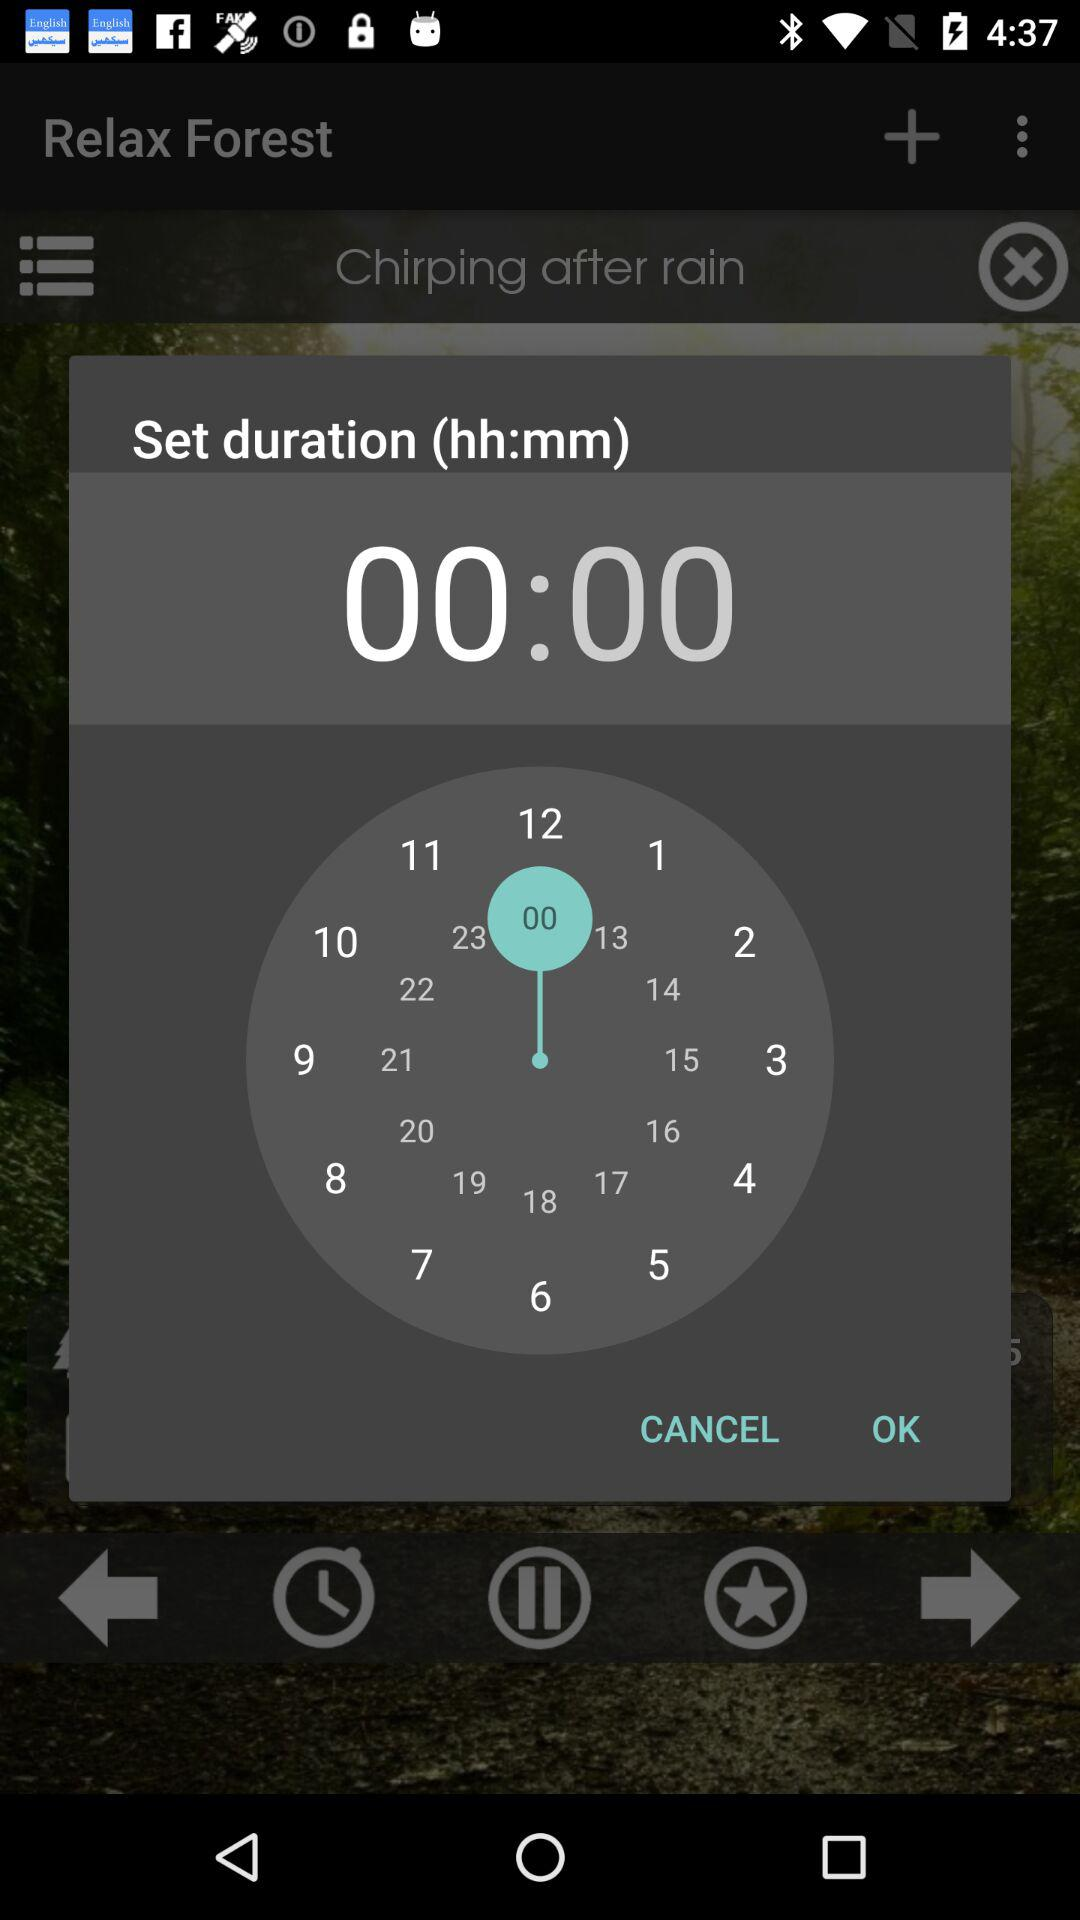What is the time selected?
When the provided information is insufficient, respond with <no answer>. <no answer> 